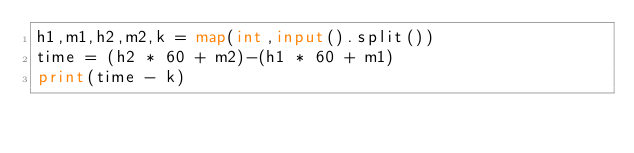Convert code to text. <code><loc_0><loc_0><loc_500><loc_500><_Python_>h1,m1,h2,m2,k = map(int,input().split())
time = (h2 * 60 + m2)-(h1 * 60 + m1)
print(time - k)
</code> 